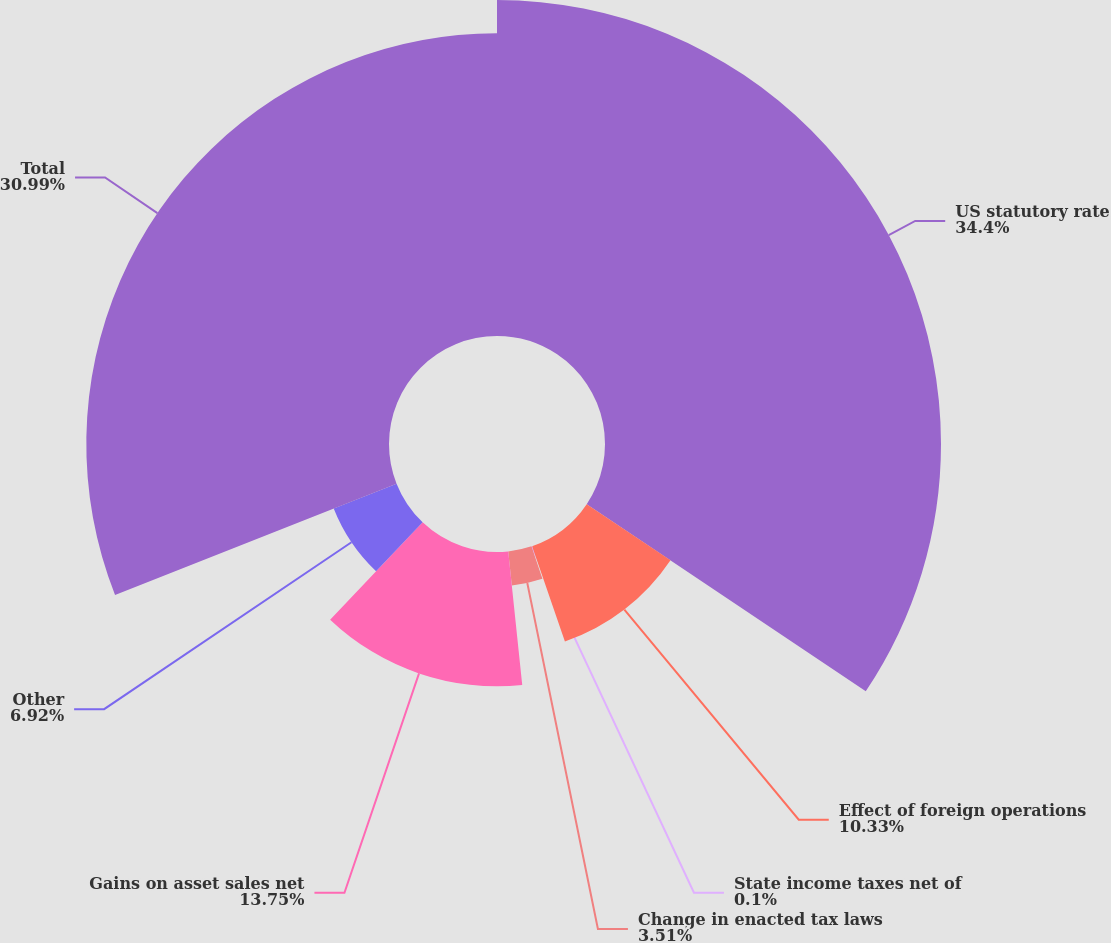Convert chart to OTSL. <chart><loc_0><loc_0><loc_500><loc_500><pie_chart><fcel>US statutory rate<fcel>Effect of foreign operations<fcel>State income taxes net of<fcel>Change in enacted tax laws<fcel>Gains on asset sales net<fcel>Other<fcel>Total<nl><fcel>34.4%<fcel>10.33%<fcel>0.1%<fcel>3.51%<fcel>13.75%<fcel>6.92%<fcel>30.99%<nl></chart> 